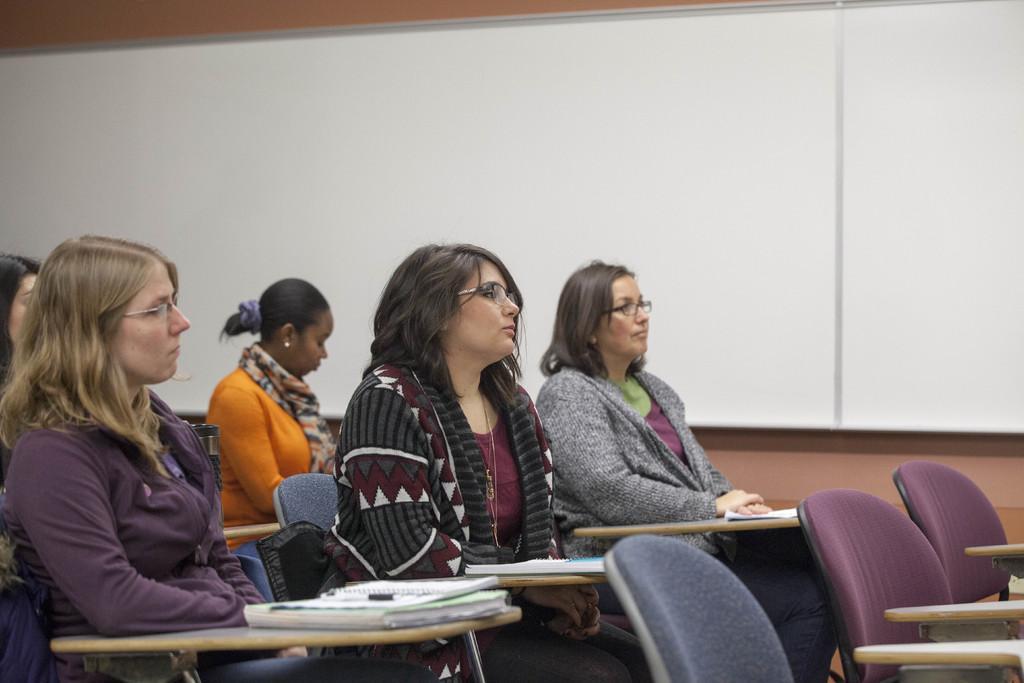Can you describe this image briefly? This image seems like a class room in which there are five woman who are sitting in the chair. There is table in front of them on which there are books and pens. At the background there is a white board which is kept on the wall. 